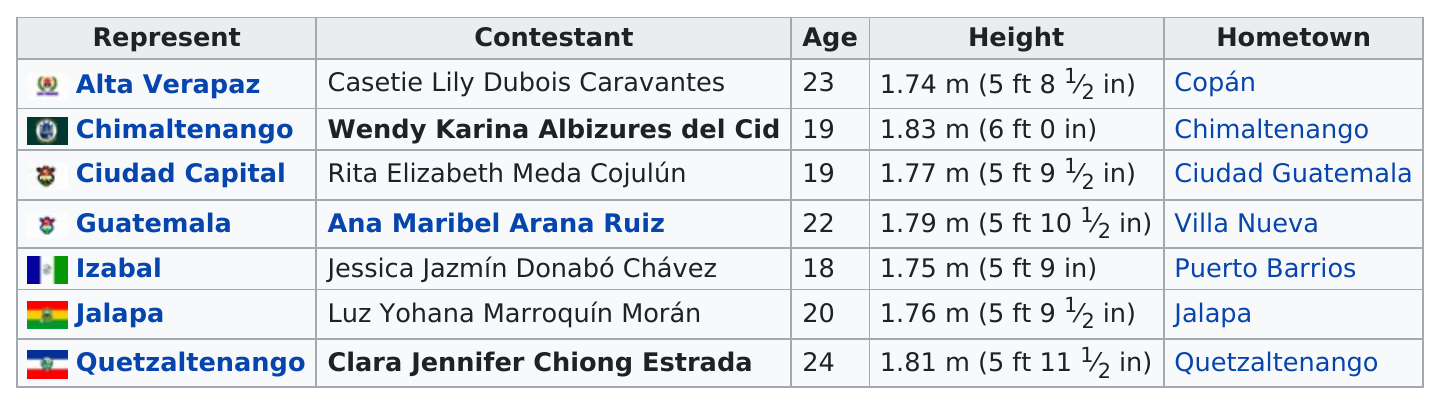Specify some key components in this picture. The delegate from Villa Nueva is taller than the delegate from Jalapa. The delegate from Jalapa is older than the delegate for Izabal. In addition to Chimaltenango, another region also had a 19-year-old contestant. Ciudad Capital was represented by a young individual in the talent competition. There are three delegates who are younger than 20 years old. Wendy Karina Albizures del Cid is the tallest delegate. 